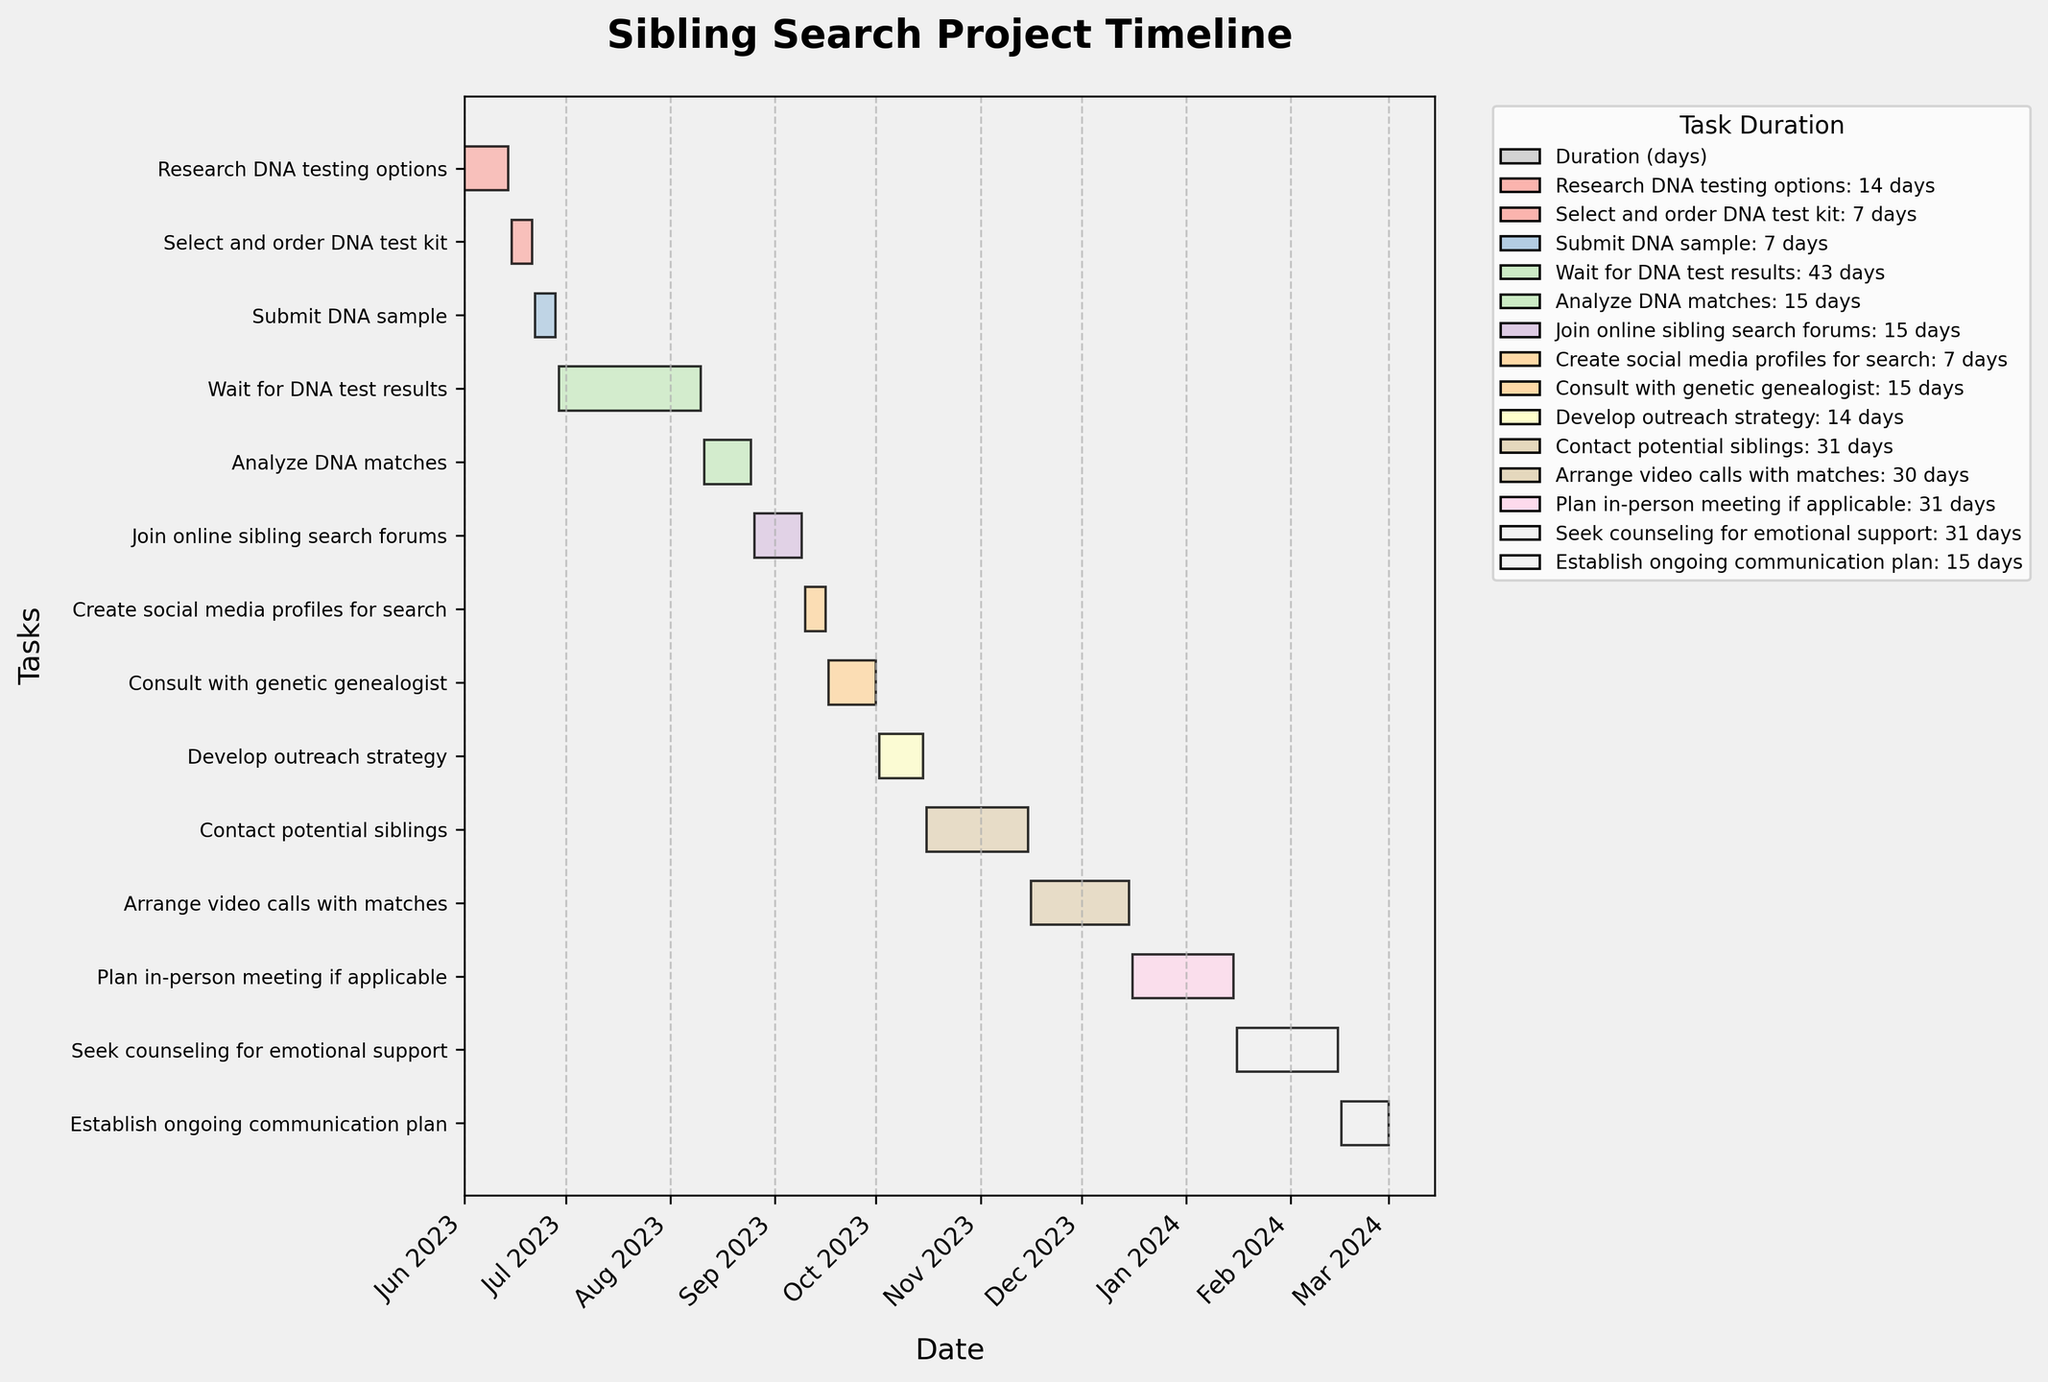What is the title of the Gantt Chart? The title of the chart is usually found at the top and indicates the main subject of the visualized data.
Answer: Sibling Search Project Timeline What task starts on July 1, 2023? By looking at the task bars aligned with the timeline, we can identify that the task corresponding to this date is "Wait for DNA test results".
Answer: Wait for DNA test results How long is the "Submit DNA sample" task? Refer to the duration of the task "Submit DNA sample" within the chart, often displayed alongside the bars or in the legend.
Answer: 7 days Which tasks take exactly 15 days? Identify the tasks by reading the durations in the chart or from the legend for each corresponding task.
Answer: Analyze DNA matches, Join online sibling search forums, Consult with genetic genealogist, Establish ongoing communication plan Which task has the longest duration? Compare the duration of each task by checking the length of the bars or their associated durations in the legend.
Answer: Wait for DNA test results How many tasks are completed after October 2023? Count the number of tasks that have their start or end dates after October 2023.
Answer: 6 tasks What is the earliest starting task? Find the task bar that begins at the earliest date on the timeline, which is usually positioned at the top.
Answer: Research DNA testing options Which task overlaps with "Consult with genetic genealogist"? Check the tasks that have bars running parallel during any period from September 17 to October 1, 2023.
Answer: Create social media profiles for search, Develop outreach strategy How many tasks start in August 2023? Identify and count the tasks that have their start dates in August 2023 on the timeline.
Answer: 2 tasks What is the total duration of all tasks combined? Sum the durations of all tasks listed in the chart. The calculation is: 14 + 7 + 7 + 43 + 15 + 15 + 7 + 15 + 14 + 31 + 30 + 31 + 31 + 15 = 305 days.
Answer: 305 days 